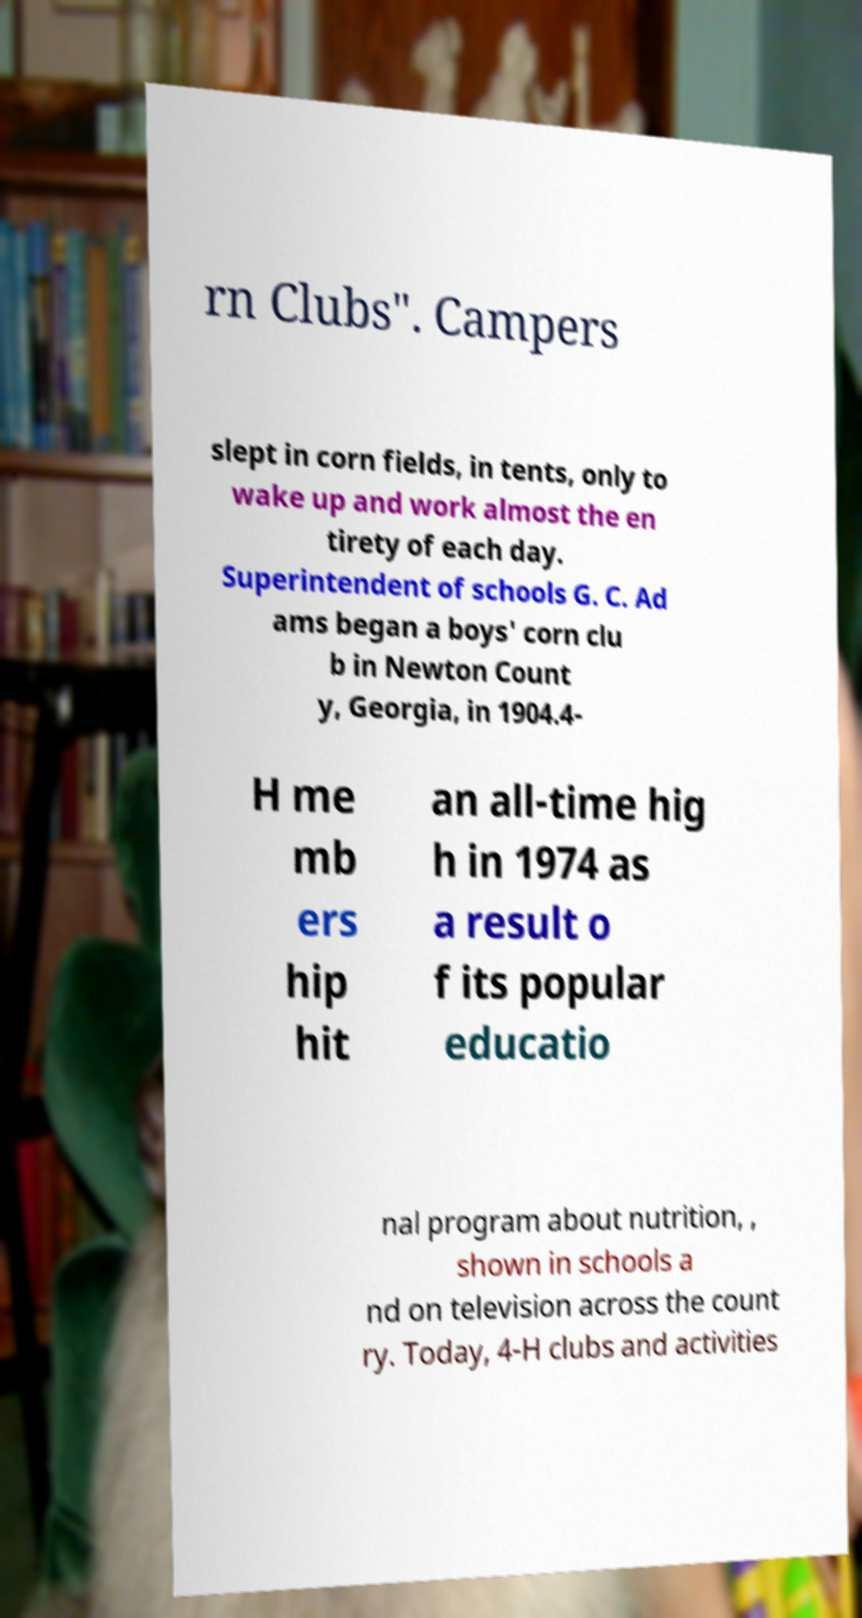Please identify and transcribe the text found in this image. rn Clubs". Campers slept in corn fields, in tents, only to wake up and work almost the en tirety of each day. Superintendent of schools G. C. Ad ams began a boys' corn clu b in Newton Count y, Georgia, in 1904.4- H me mb ers hip hit an all-time hig h in 1974 as a result o f its popular educatio nal program about nutrition, , shown in schools a nd on television across the count ry. Today, 4-H clubs and activities 